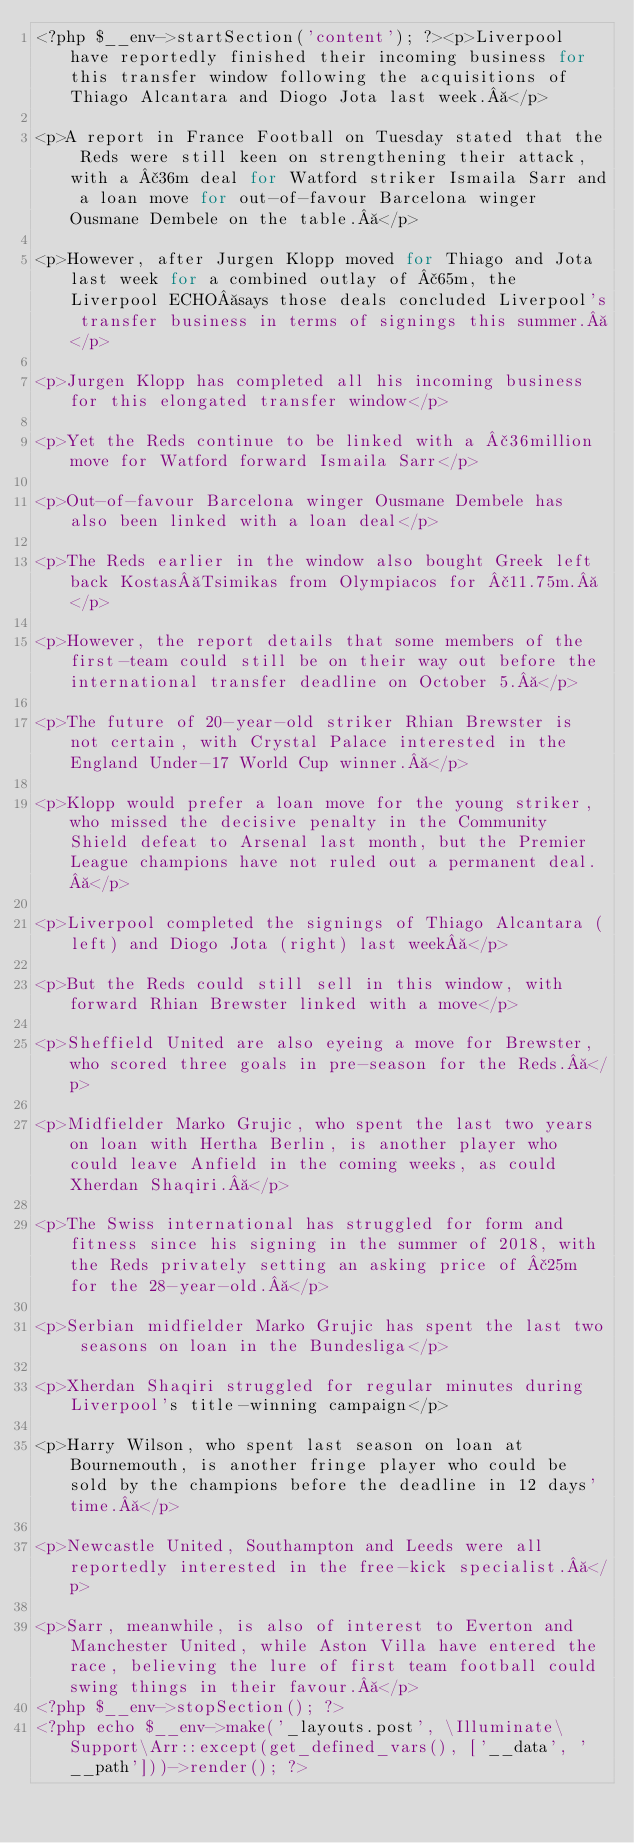<code> <loc_0><loc_0><loc_500><loc_500><_PHP_><?php $__env->startSection('content'); ?><p>Liverpool have reportedly finished their incoming business for this transfer window following the acquisitions of Thiago Alcantara and Diogo Jota last week. </p>

<p>A report in France Football on Tuesday stated that the Reds were still keen on strengthening their attack, with a £36m deal for Watford striker Ismaila Sarr and a loan move for out-of-favour Barcelona winger Ousmane Dembele on the table. </p>

<p>However, after Jurgen Klopp moved for Thiago and Jota last week for a combined outlay of £65m, the Liverpool ECHO says those deals concluded Liverpool's transfer business in terms of signings this summer. </p>

<p>Jurgen Klopp has completed all his incoming business for this elongated transfer window</p>

<p>Yet the Reds continue to be linked with a £36million move for Watford forward Ismaila Sarr</p>

<p>Out-of-favour Barcelona winger Ousmane Dembele has also been linked with a loan deal</p>

<p>The Reds earlier in the window also bought Greek left back Kostas Tsimikas from Olympiacos for £11.75m. </p>

<p>However, the report details that some members of the first-team could still be on their way out before the international transfer deadline on October 5. </p>

<p>The future of 20-year-old striker Rhian Brewster is not certain, with Crystal Palace interested in the England Under-17 World Cup winner. </p>

<p>Klopp would prefer a loan move for the young striker, who missed the decisive penalty in the Community Shield defeat to Arsenal last month, but the Premier League champions have not ruled out a permanent deal. </p>

<p>Liverpool completed the signings of Thiago Alcantara (left) and Diogo Jota (right) last week </p>

<p>But the Reds could still sell in this window, with forward Rhian Brewster linked with a move</p>

<p>Sheffield United are also eyeing a move for Brewster, who scored three goals in pre-season for the Reds. </p>

<p>Midfielder Marko Grujic, who spent the last two years on loan with Hertha Berlin, is another player who could leave Anfield in the coming weeks, as could Xherdan Shaqiri. </p>

<p>The Swiss international has struggled for form and fitness since his signing in the summer of 2018, with the Reds privately setting an asking price of £25m for the 28-year-old. </p>

<p>Serbian midfielder Marko Grujic has spent the last two seasons on loan in the Bundesliga</p>

<p>Xherdan Shaqiri struggled for regular minutes during Liverpool's title-winning campaign</p>

<p>Harry Wilson, who spent last season on loan at Bournemouth, is another fringe player who could be sold by the champions before the deadline in 12 days' time. </p>

<p>Newcastle United, Southampton and Leeds were all reportedly interested in the free-kick specialist. </p>

<p>Sarr, meanwhile, is also of interest to Everton and Manchester United, while Aston Villa have entered the race, believing the lure of first team football could swing things in their favour. </p>
<?php $__env->stopSection(); ?>
<?php echo $__env->make('_layouts.post', \Illuminate\Support\Arr::except(get_defined_vars(), ['__data', '__path']))->render(); ?></code> 